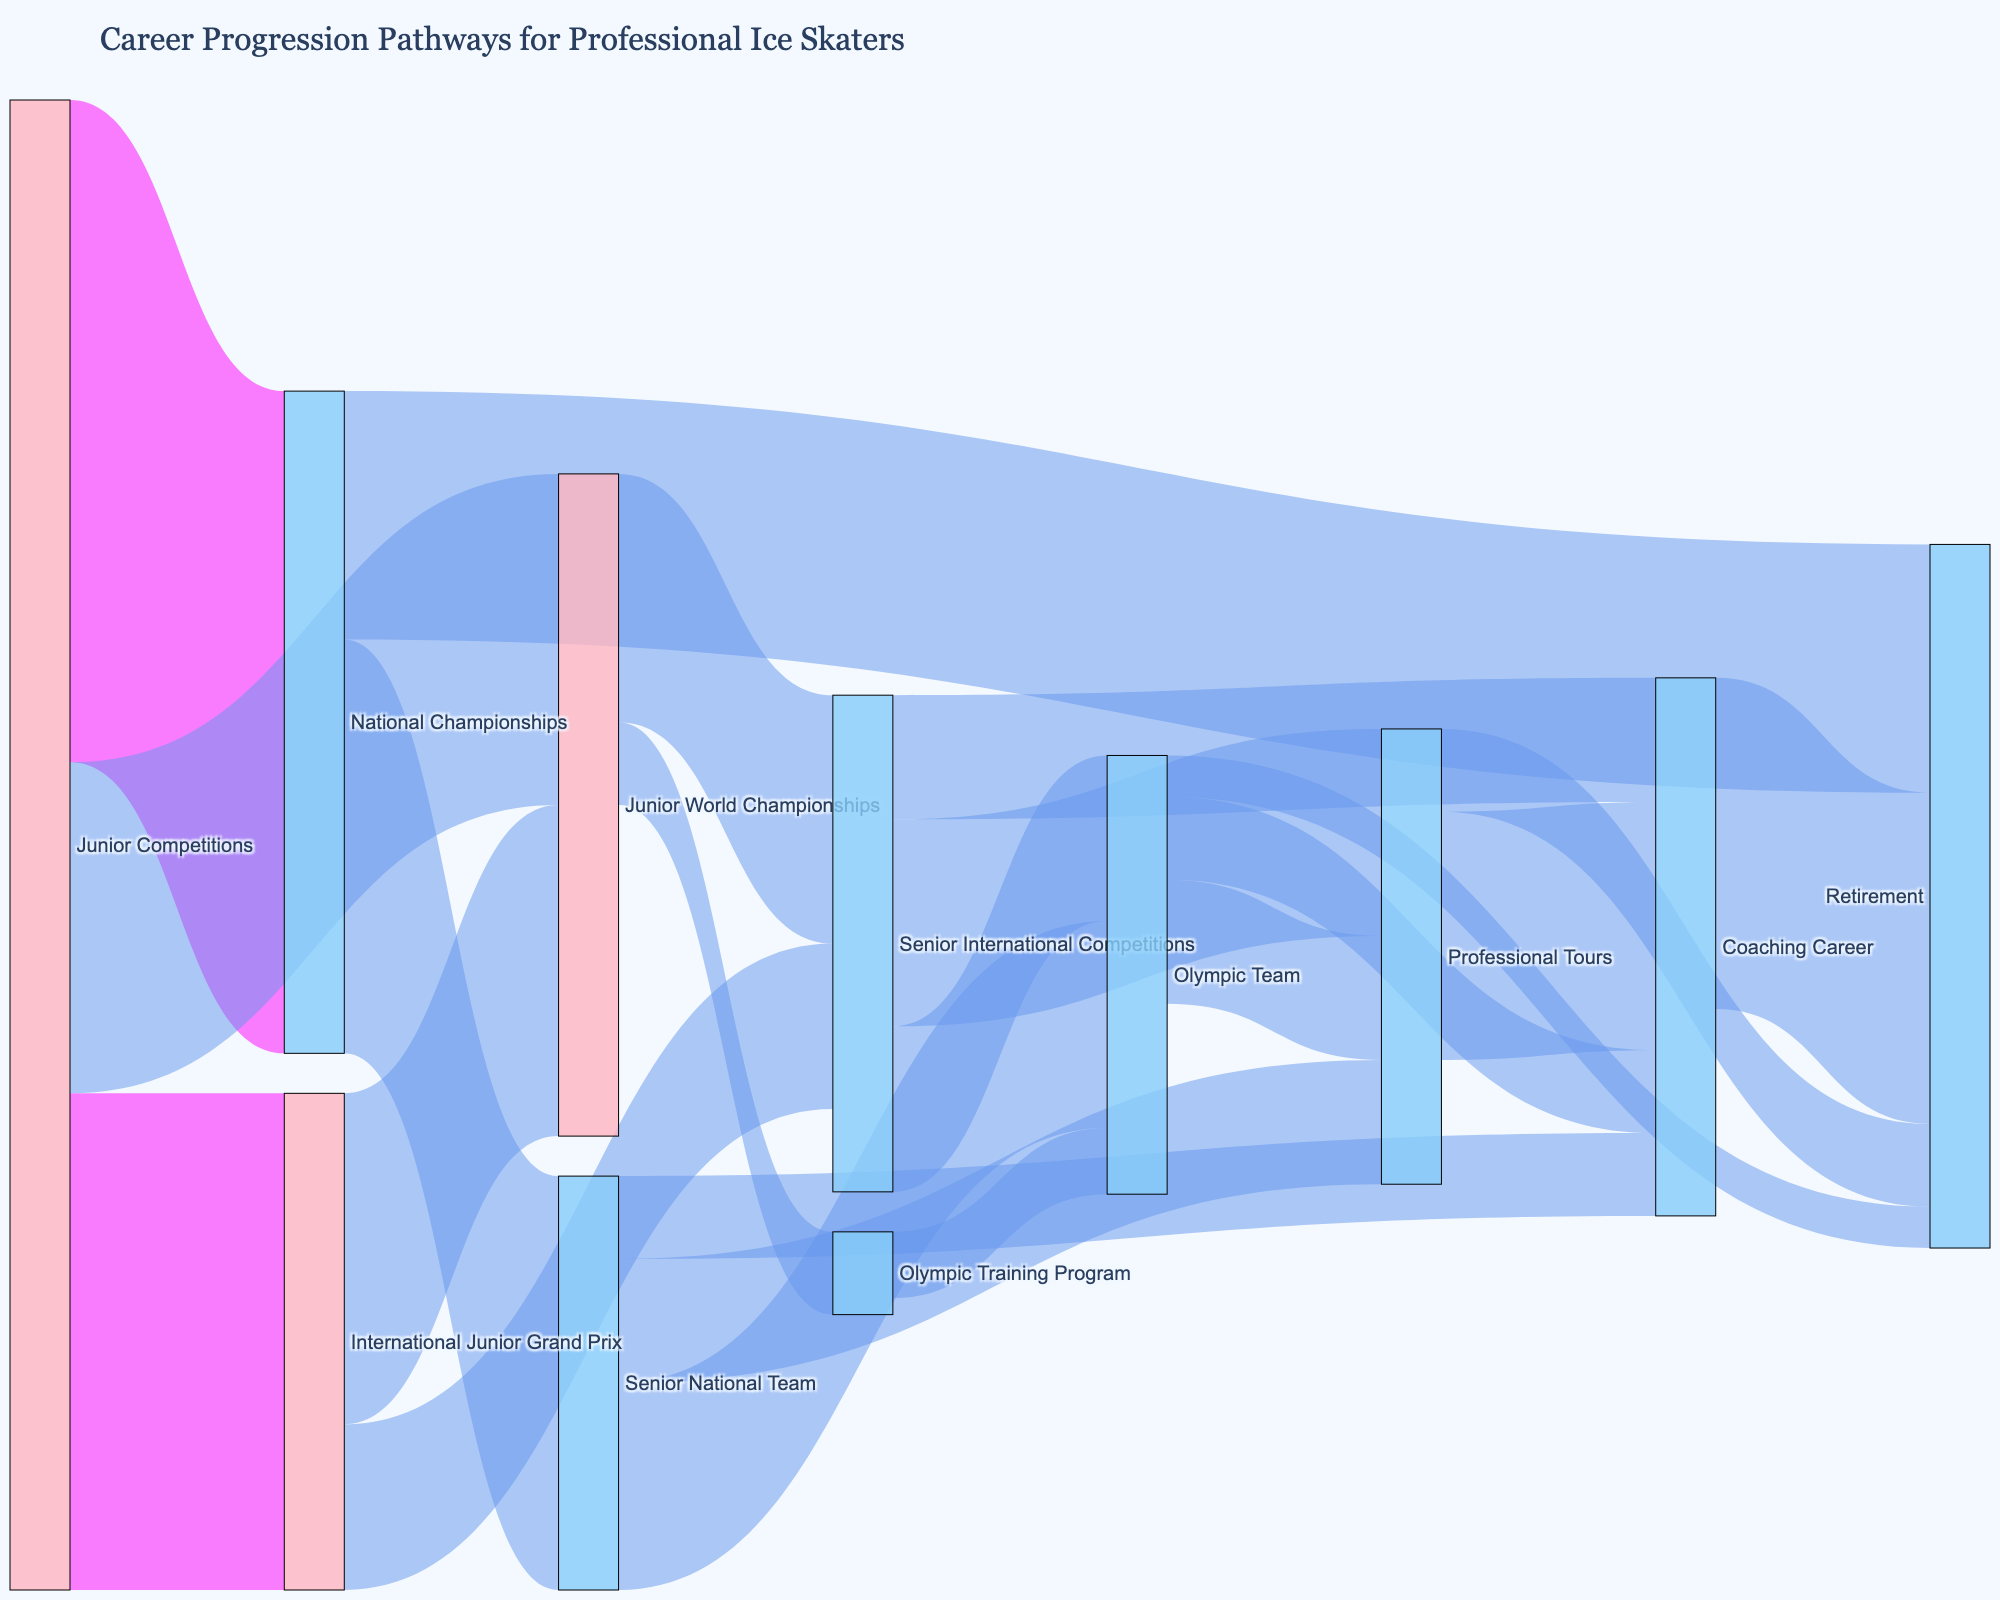What is the title of the Sankey diagram? The title is located at the top of the figure and reads "Career Progression Pathways for Professional Ice Skaters".
Answer: Career Progression Pathways for Professional Ice Skaters Which pathway from the "Junior Competitions" node has the highest value? The endpoints of the pathways from "Junior Competitions" lead to "National Championships" (80), "International Junior Grand Prix" (60), and "Junior World Championships" (40). The highest value is 80 for the "National Championships" pathway.
Answer: National Championships What is the total value of skaters progressing to the "Olympic Team"? Summing up the values of all pathways leading to "Olympic Team", which are from "Senior National Team" (25), "Senior International Competitions" (20), and "Olympic Training Program" (8), we get 25 + 20 + 8 = 53.
Answer: 53 Compare the number of skaters who retire after the "National Championships" and after "Professional Tours". Which is higher? The "National Championships" to "Retirement" pathway has a value of 30, and the "Professional Tours" to "Retirement" pathway has a value of 10. Comparing these, 30 is higher.
Answer: National Championships How many different pathways lead to the "Coaching Career"? The endpoints leading to "Coaching Career" are from "Senior National Team" (10), "Senior International Competitions" (15), "Olympic Team" (10), and "Professional Tours" (30), making a total of 4 pathways.
Answer: 4 What is the total value from "Junior World Championships" moving to other nodes? The total value is the sum of the pathways: "Senior International Competitions" (30) and "Olympic Training Program" (10). Thus, 30 + 10 = 40.
Answer: 40 Which color represents pathways with a value greater than 50? By identifying the color scheme, pathways with values greater than 50 use a specific color different from others, noted as a semi-transparent purple.
Answer: semi-transparent purple What’s the cumulative value of skaters transitioning from "Senior International Competitions"? Adding the pathway values from "Senior International Competitions" to "Olympic Team" (20), "Professional Tours" (25), and "Coaching Career" (15) results in 20 + 25 + 15 = 60.
Answer: 60 Consider the pathway transitions from "Olympic Team". What percentage of skaters move into a "Coaching Career"? "Olympic Team" to "Coaching Career" has a value of 10, out of the total 25+15+10+5 = 55 for "Olympic Team". The percentage is (10/55) * 100% which simplifies to approximately 18.18%.
Answer: 18.18% Which node has the highest number of incoming pathways? By counting the incoming pathways to each node, "Coaching Career" has 4 pathways, which is the highest number of incoming pathways.
Answer: Coaching Career 